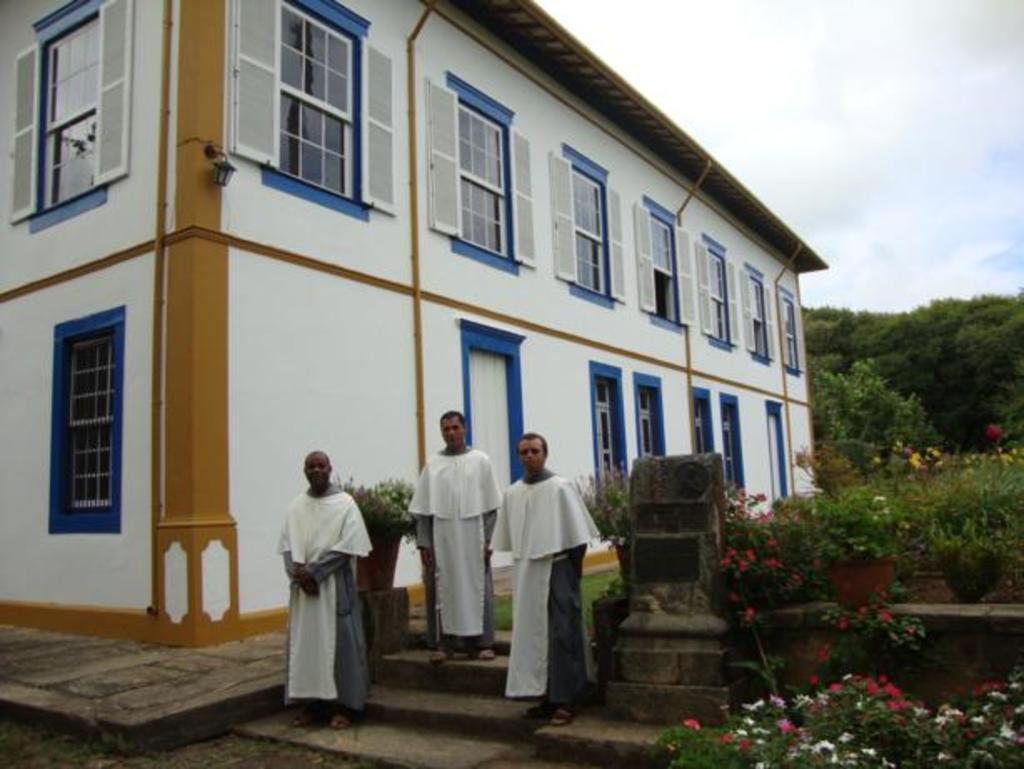How many men are standing on the steps in the image? There are three men standing on the steps in the image. What can be seen on the right side of the image? There are plants on the right side of the image. What is visible in the background of the image? There is a tree, windows, and a door in the background of the image. What reason does the tree give for being in the background of the image? Trees do not have the ability to give reasons, as they are inanimate objects. 